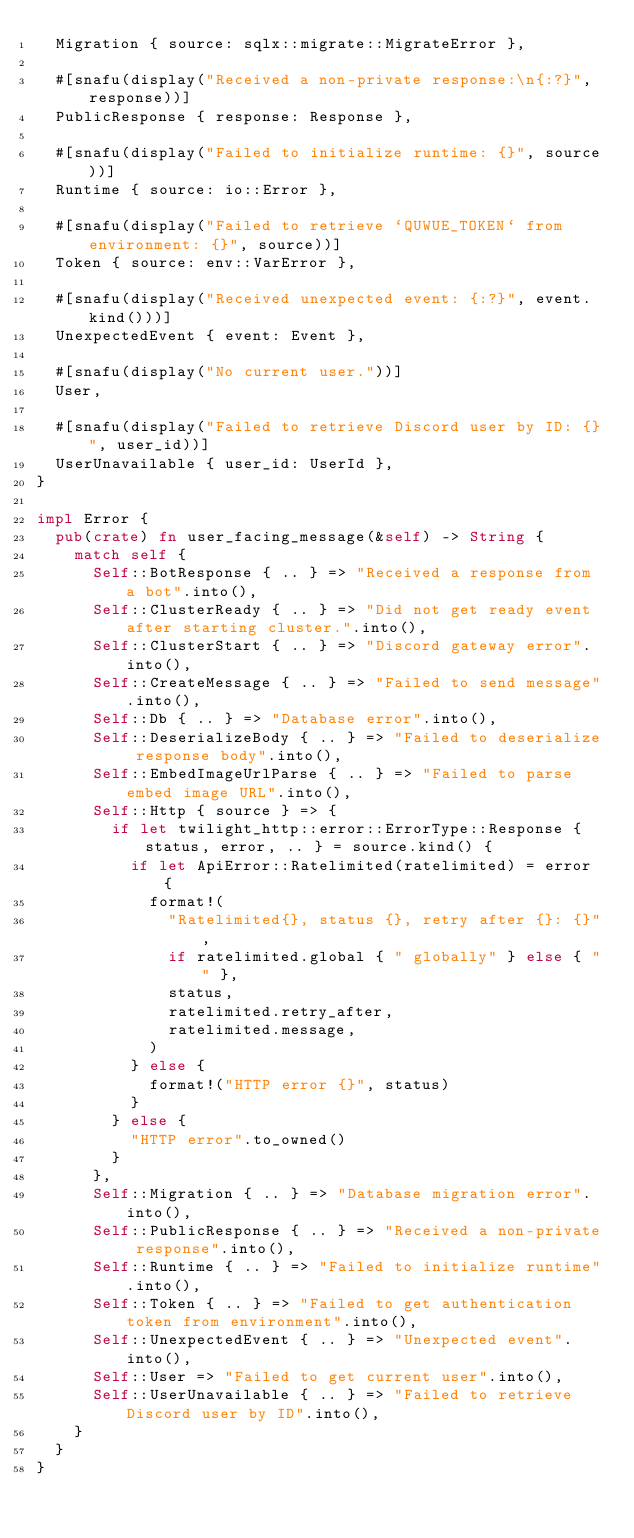Convert code to text. <code><loc_0><loc_0><loc_500><loc_500><_Rust_>  Migration { source: sqlx::migrate::MigrateError },

  #[snafu(display("Received a non-private response:\n{:?}", response))]
  PublicResponse { response: Response },

  #[snafu(display("Failed to initialize runtime: {}", source))]
  Runtime { source: io::Error },

  #[snafu(display("Failed to retrieve `QUWUE_TOKEN` from environment: {}", source))]
  Token { source: env::VarError },

  #[snafu(display("Received unexpected event: {:?}", event.kind()))]
  UnexpectedEvent { event: Event },

  #[snafu(display("No current user."))]
  User,

  #[snafu(display("Failed to retrieve Discord user by ID: {}", user_id))]
  UserUnavailable { user_id: UserId },
}

impl Error {
  pub(crate) fn user_facing_message(&self) -> String {
    match self {
      Self::BotResponse { .. } => "Received a response from a bot".into(),
      Self::ClusterReady { .. } => "Did not get ready event after starting cluster.".into(),
      Self::ClusterStart { .. } => "Discord gateway error".into(),
      Self::CreateMessage { .. } => "Failed to send message".into(),
      Self::Db { .. } => "Database error".into(),
      Self::DeserializeBody { .. } => "Failed to deserialize response body".into(),
      Self::EmbedImageUrlParse { .. } => "Failed to parse embed image URL".into(),
      Self::Http { source } => {
        if let twilight_http::error::ErrorType::Response { status, error, .. } = source.kind() {
          if let ApiError::Ratelimited(ratelimited) = error {
            format!(
              "Ratelimited{}, status {}, retry after {}: {}",
              if ratelimited.global { " globally" } else { "" },
              status,
              ratelimited.retry_after,
              ratelimited.message,
            )
          } else {
            format!("HTTP error {}", status)
          }
        } else {
          "HTTP error".to_owned()
        }
      },
      Self::Migration { .. } => "Database migration error".into(),
      Self::PublicResponse { .. } => "Received a non-private response".into(),
      Self::Runtime { .. } => "Failed to initialize runtime".into(),
      Self::Token { .. } => "Failed to get authentication token from environment".into(),
      Self::UnexpectedEvent { .. } => "Unexpected event".into(),
      Self::User => "Failed to get current user".into(),
      Self::UserUnavailable { .. } => "Failed to retrieve Discord user by ID".into(),
    }
  }
}
</code> 